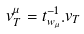<formula> <loc_0><loc_0><loc_500><loc_500>v _ { T } ^ { \mu } = t _ { w _ { \mu } } ^ { - 1 } . v _ { T }</formula> 